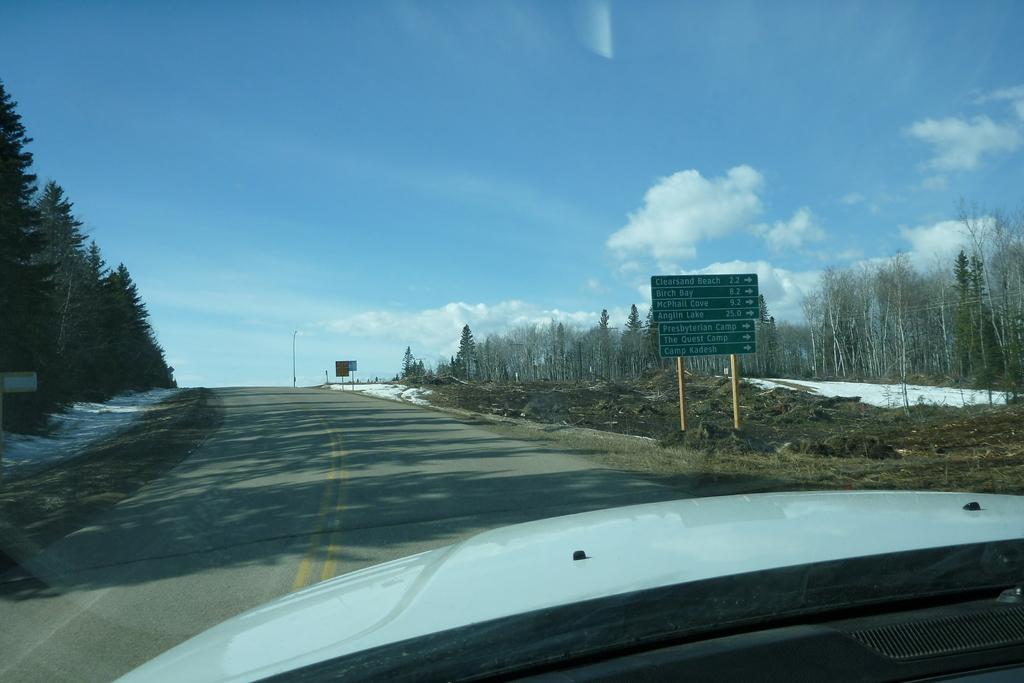What is the main subject of the image? There is a vehicle in the image. What can be seen near the vehicle? Direction boards are present in the image. What type of surface is visible in the image? There is a road in the image. What type of natural elements can be seen in the image? Trees are visible in the image. What type of man-made structures are present in the image? Poles are present in the image. Are there any other objects in the image besides the vehicle, direction boards, road, trees, and poles? Yes, there are other objects in the image. What is visible in the background of the image? The sky is visible in the background of the image. What can be seen in the sky? Clouds are present in the sky. Where is the aunt sitting with her mitten in the image? There is no aunt or mitten present in the image. How many trucks are visible in the image? There are no trucks visible in the image. 